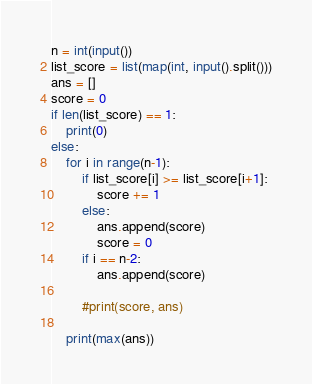<code> <loc_0><loc_0><loc_500><loc_500><_Python_>n = int(input())
list_score = list(map(int, input().split()))
ans = []
score = 0
if len(list_score) == 1:
    print(0)
else:
    for i in range(n-1):
        if list_score[i] >= list_score[i+1]:
            score += 1
        else:
            ans.append(score)
            score = 0
        if i == n-2:
            ans.append(score)

        #print(score, ans)

    print(max(ans))</code> 